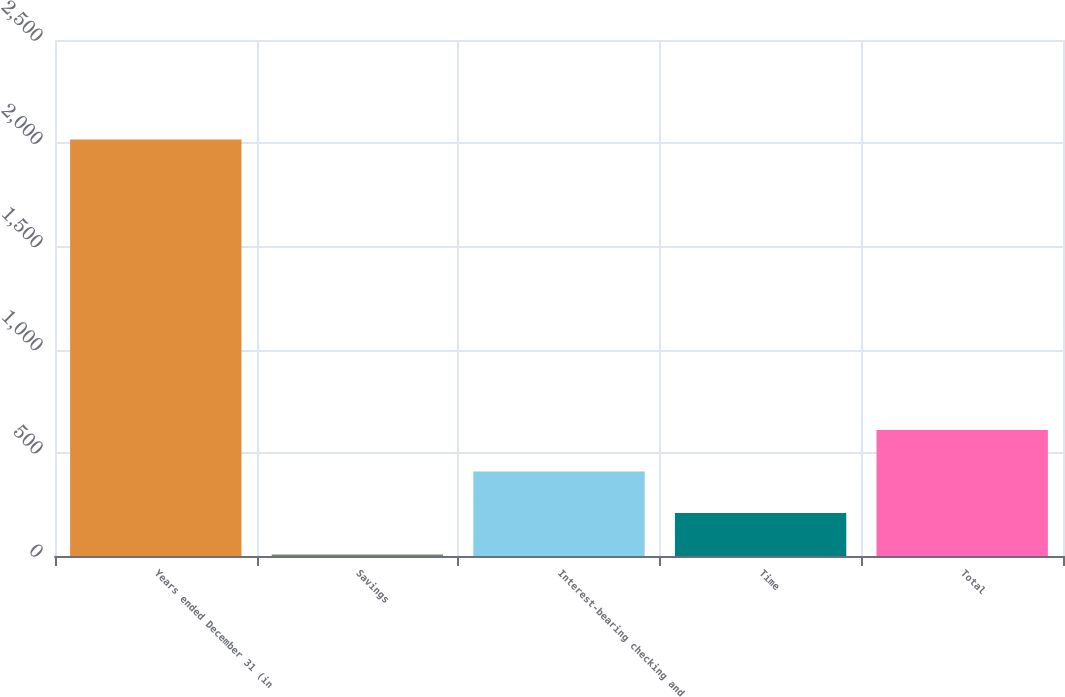<chart> <loc_0><loc_0><loc_500><loc_500><bar_chart><fcel>Years ended December 31 (in<fcel>Savings<fcel>Interest-bearing checking and<fcel>Time<fcel>Total<nl><fcel>2018<fcel>7.2<fcel>409.36<fcel>208.28<fcel>610.44<nl></chart> 